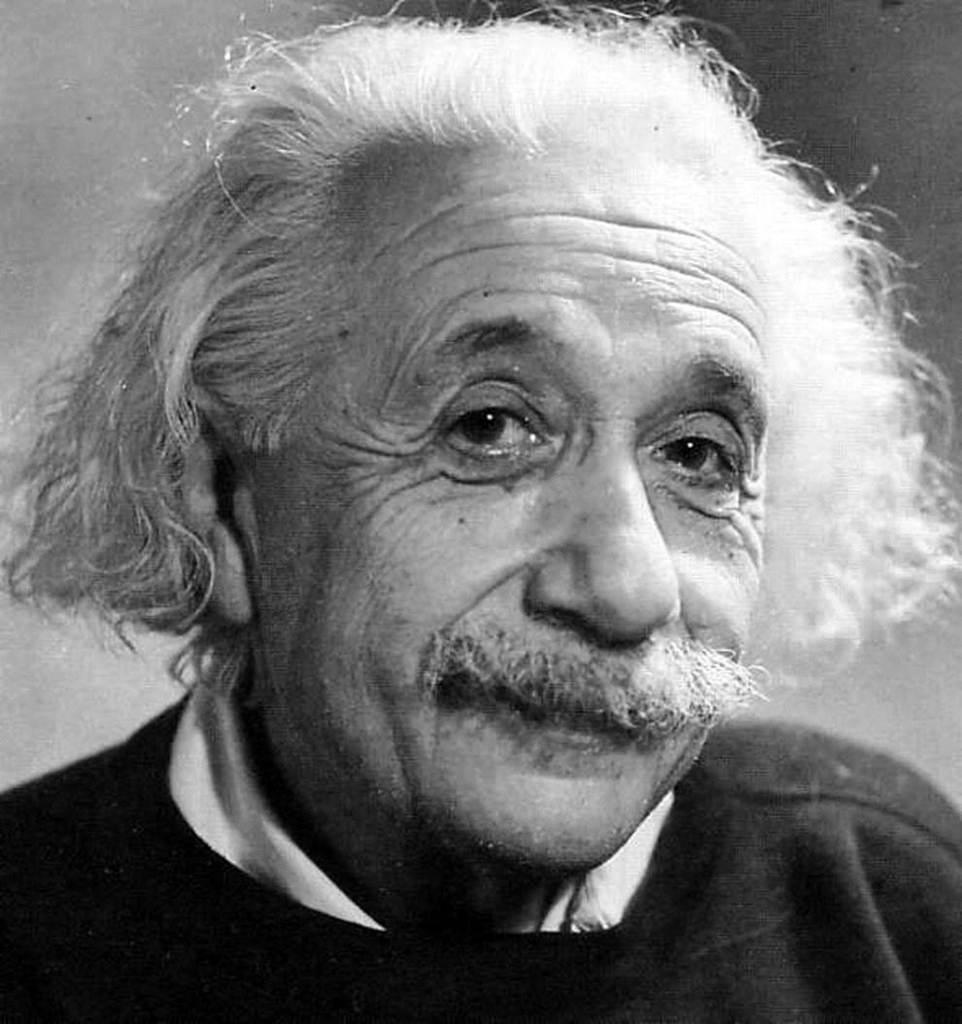Could you give a brief overview of what you see in this image? This is a black and white image. In the center of the image a man is present. 